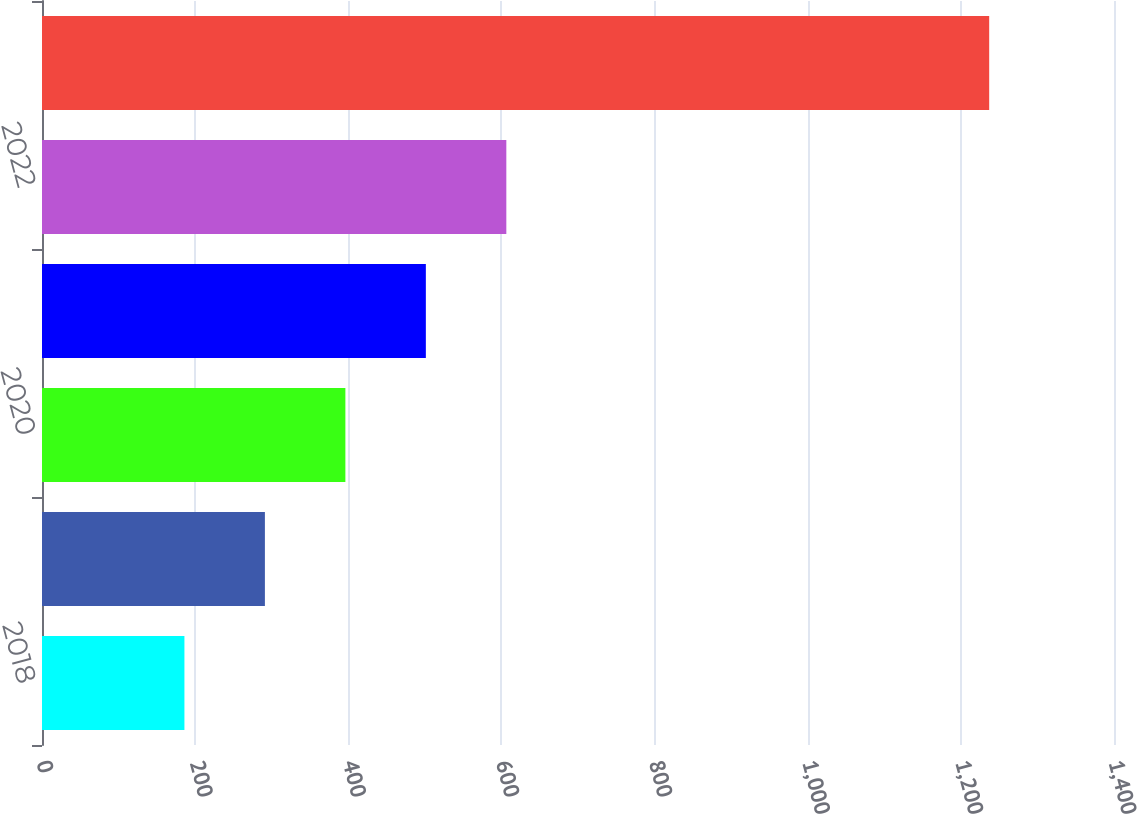Convert chart. <chart><loc_0><loc_0><loc_500><loc_500><bar_chart><fcel>2018<fcel>2019<fcel>2020<fcel>2021<fcel>2022<fcel>2023 - 2027<nl><fcel>186<fcel>291.1<fcel>396.2<fcel>501.3<fcel>606.4<fcel>1237<nl></chart> 